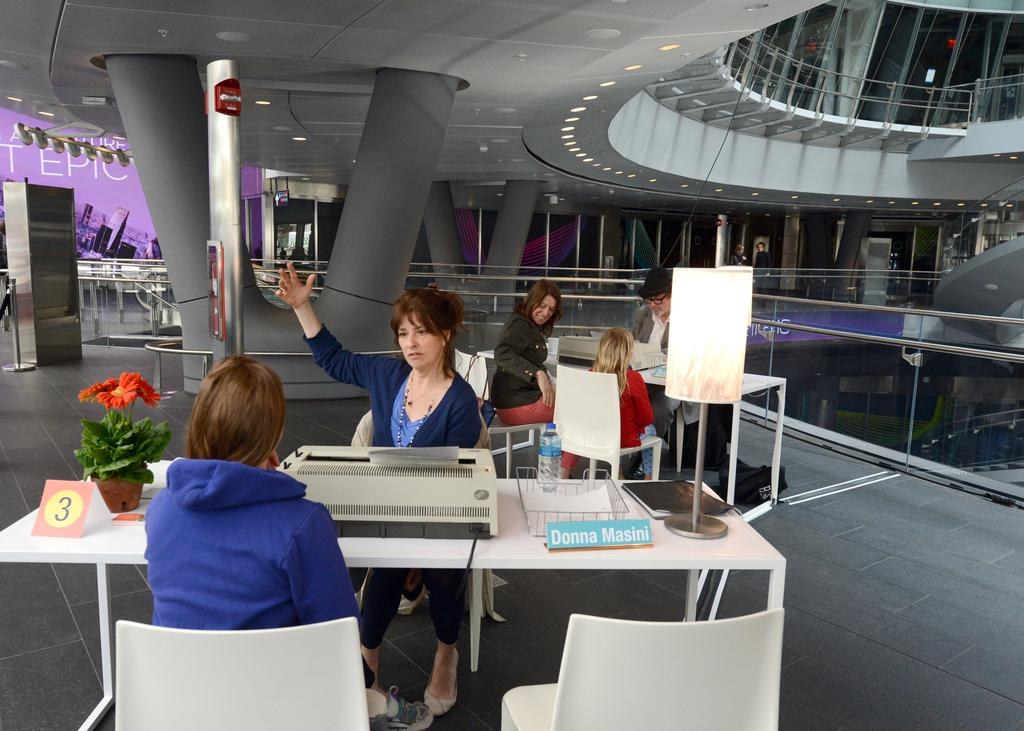What are the people in the image doing? The people in the image are sitting on chairs. What is present in the image besides the people? There is a table in the image. What objects can be seen on the table? There is a printer machine, a water bottle, and a name plate on the table. What type of punishment is being given to the root in the image? There is no punishment or root present in the image; it features people sitting on chairs, a table, and objects on the table. 